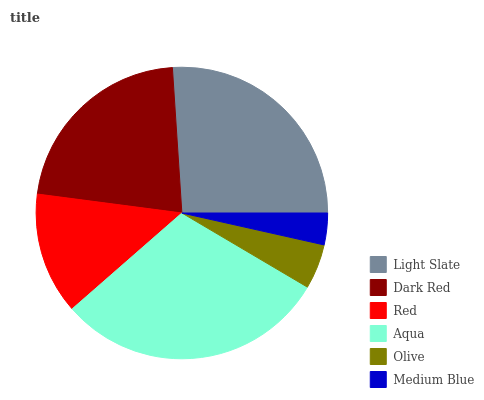Is Medium Blue the minimum?
Answer yes or no. Yes. Is Aqua the maximum?
Answer yes or no. Yes. Is Dark Red the minimum?
Answer yes or no. No. Is Dark Red the maximum?
Answer yes or no. No. Is Light Slate greater than Dark Red?
Answer yes or no. Yes. Is Dark Red less than Light Slate?
Answer yes or no. Yes. Is Dark Red greater than Light Slate?
Answer yes or no. No. Is Light Slate less than Dark Red?
Answer yes or no. No. Is Dark Red the high median?
Answer yes or no. Yes. Is Red the low median?
Answer yes or no. Yes. Is Light Slate the high median?
Answer yes or no. No. Is Dark Red the low median?
Answer yes or no. No. 